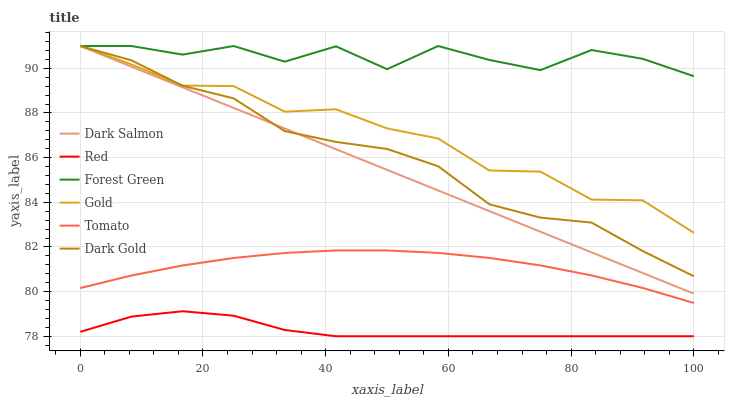Does Red have the minimum area under the curve?
Answer yes or no. Yes. Does Forest Green have the maximum area under the curve?
Answer yes or no. Yes. Does Gold have the minimum area under the curve?
Answer yes or no. No. Does Gold have the maximum area under the curve?
Answer yes or no. No. Is Dark Salmon the smoothest?
Answer yes or no. Yes. Is Forest Green the roughest?
Answer yes or no. Yes. Is Gold the smoothest?
Answer yes or no. No. Is Gold the roughest?
Answer yes or no. No. Does Gold have the lowest value?
Answer yes or no. No. Does Forest Green have the highest value?
Answer yes or no. Yes. Does Red have the highest value?
Answer yes or no. No. Is Tomato less than Dark Salmon?
Answer yes or no. Yes. Is Dark Salmon greater than Red?
Answer yes or no. Yes. Does Gold intersect Dark Gold?
Answer yes or no. Yes. Is Gold less than Dark Gold?
Answer yes or no. No. Is Gold greater than Dark Gold?
Answer yes or no. No. Does Tomato intersect Dark Salmon?
Answer yes or no. No. 